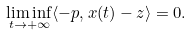<formula> <loc_0><loc_0><loc_500><loc_500>\liminf _ { t \rightarrow + \infty } \langle - p , x ( t ) - z \rangle = 0 .</formula> 